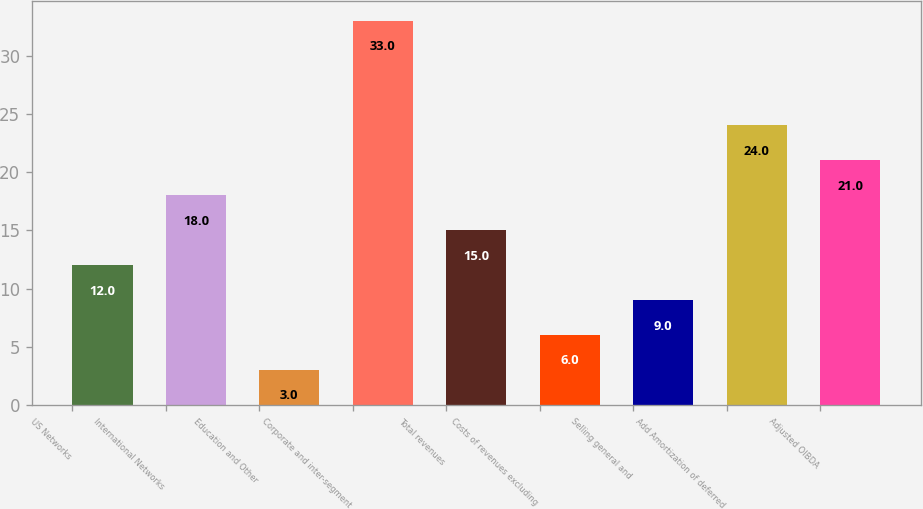<chart> <loc_0><loc_0><loc_500><loc_500><bar_chart><fcel>US Networks<fcel>International Networks<fcel>Education and Other<fcel>Corporate and inter-segment<fcel>Total revenues<fcel>Costs of revenues excluding<fcel>Selling general and<fcel>Add Amortization of deferred<fcel>Adjusted OIBDA<nl><fcel>12<fcel>18<fcel>3<fcel>33<fcel>15<fcel>6<fcel>9<fcel>24<fcel>21<nl></chart> 